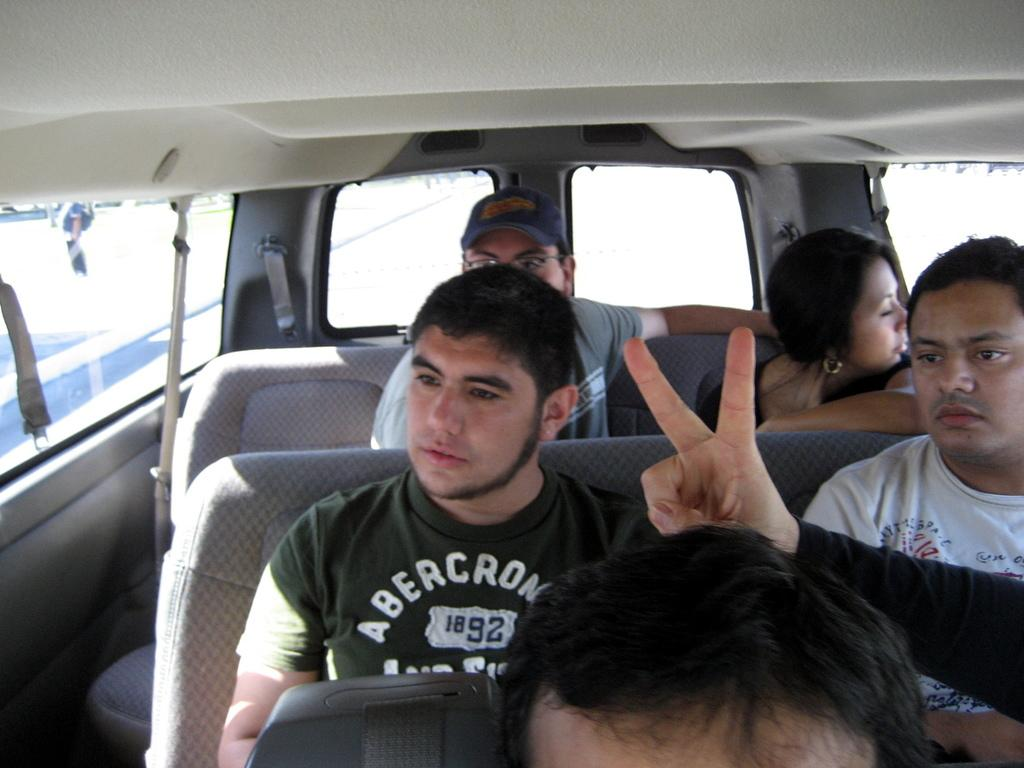Who or what can be seen in the image? There are people in the image. What are the people doing in the image? The people are sitting in a vehicle. What type of crib is visible in the image? There is no crib present in the image. What kind of apparel are the people wearing in the image? The provided facts do not mention the apparel of the people in the image. Is there any soda visible in the image? The provided facts do not mention any soda in the image. 